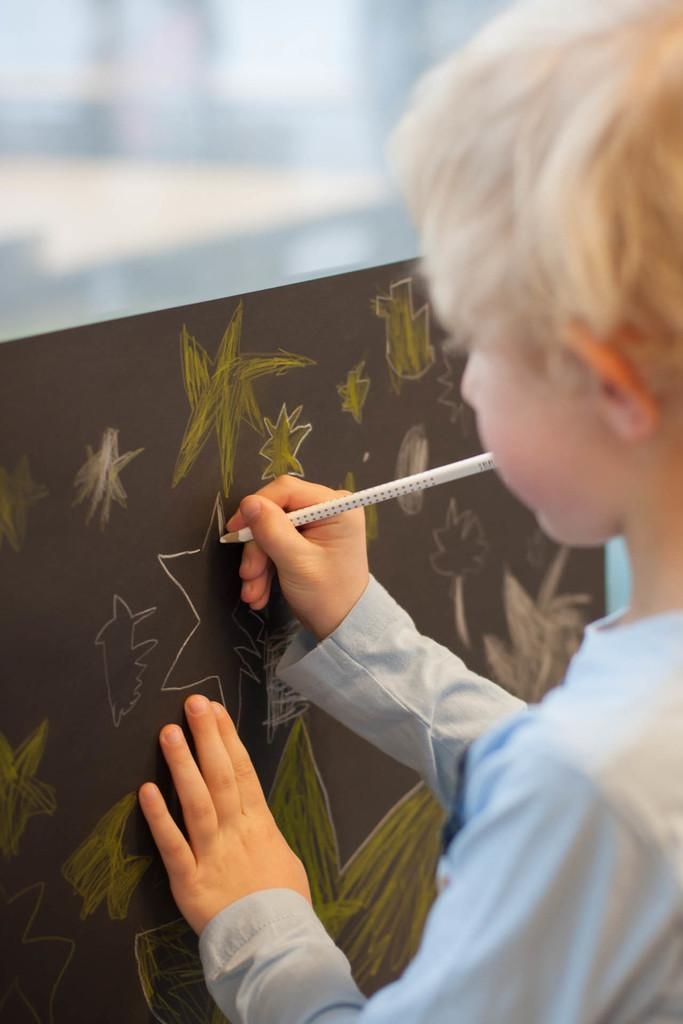What is the main subject of the image? There is a child in the image. What is the child doing in the image? The child is standing in the image. What object is the child holding? The child is holding a pencil in the image. What is in front of the child? There is a board in front of the child. What can be seen on the board? The board has pictures on it. What type of juice is the child drinking in the image? There is no juice present in the image; the child is holding a pencil and standing in front of a board with pictures on it. 